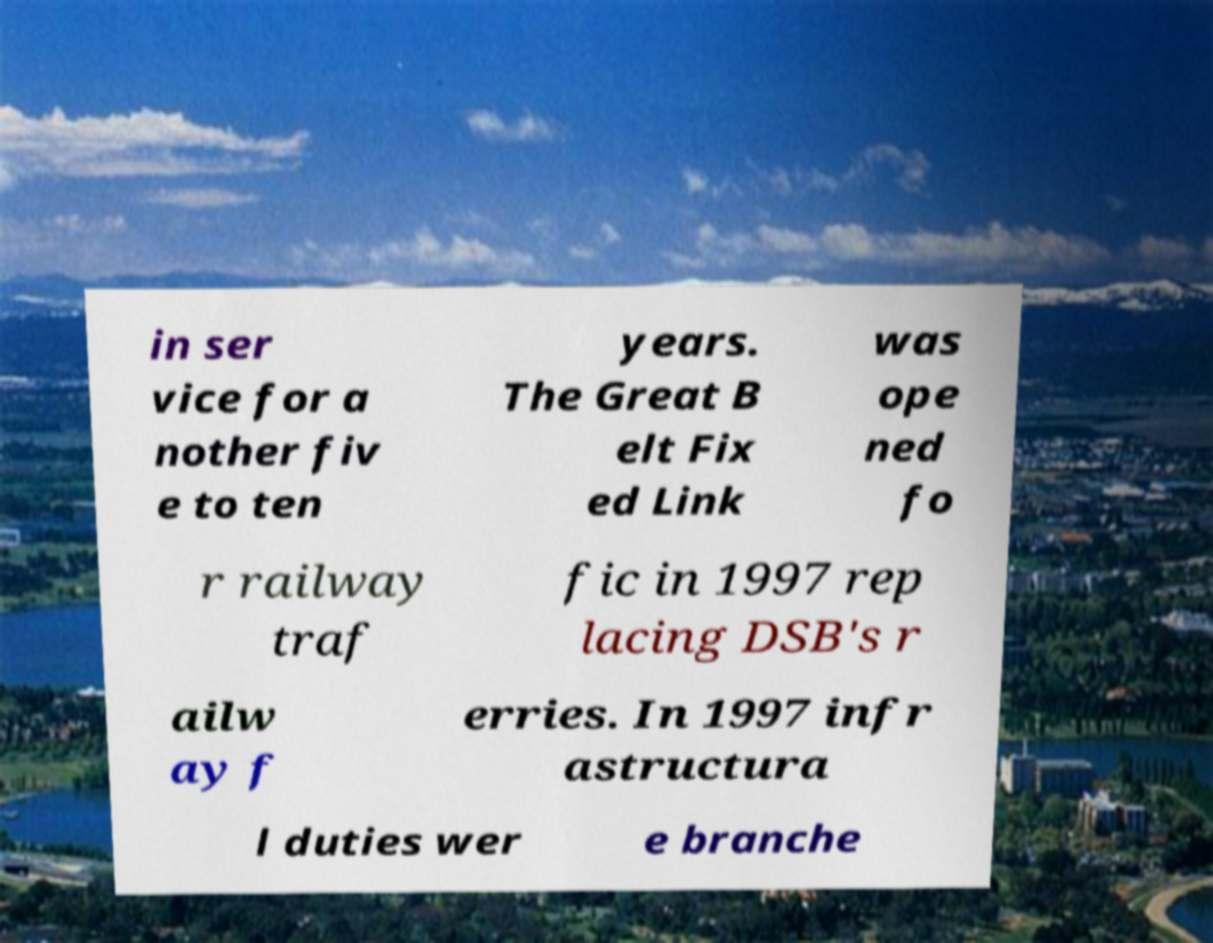I need the written content from this picture converted into text. Can you do that? in ser vice for a nother fiv e to ten years. The Great B elt Fix ed Link was ope ned fo r railway traf fic in 1997 rep lacing DSB's r ailw ay f erries. In 1997 infr astructura l duties wer e branche 